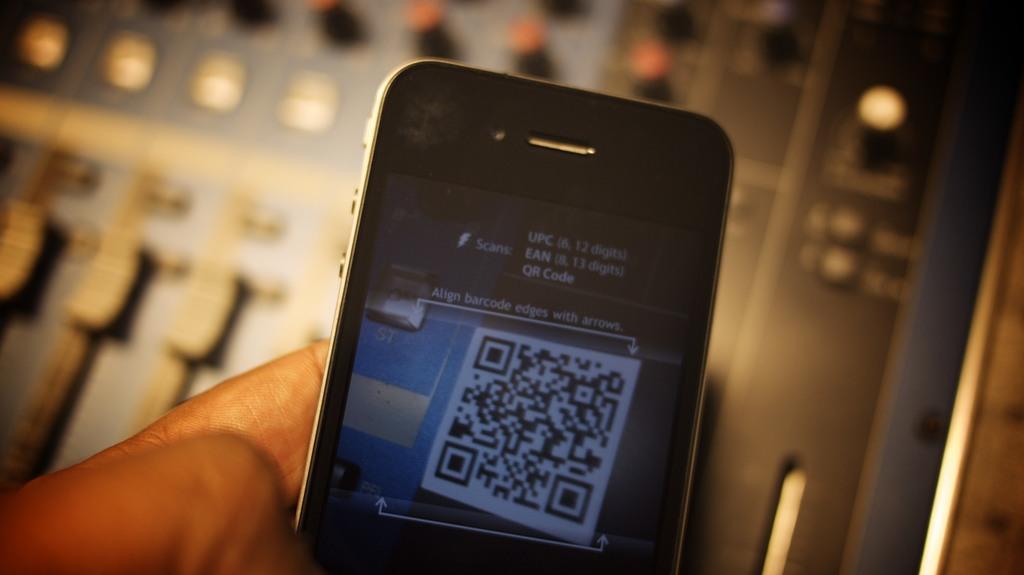How many digits does the code have?
Your answer should be very brief. 12. 